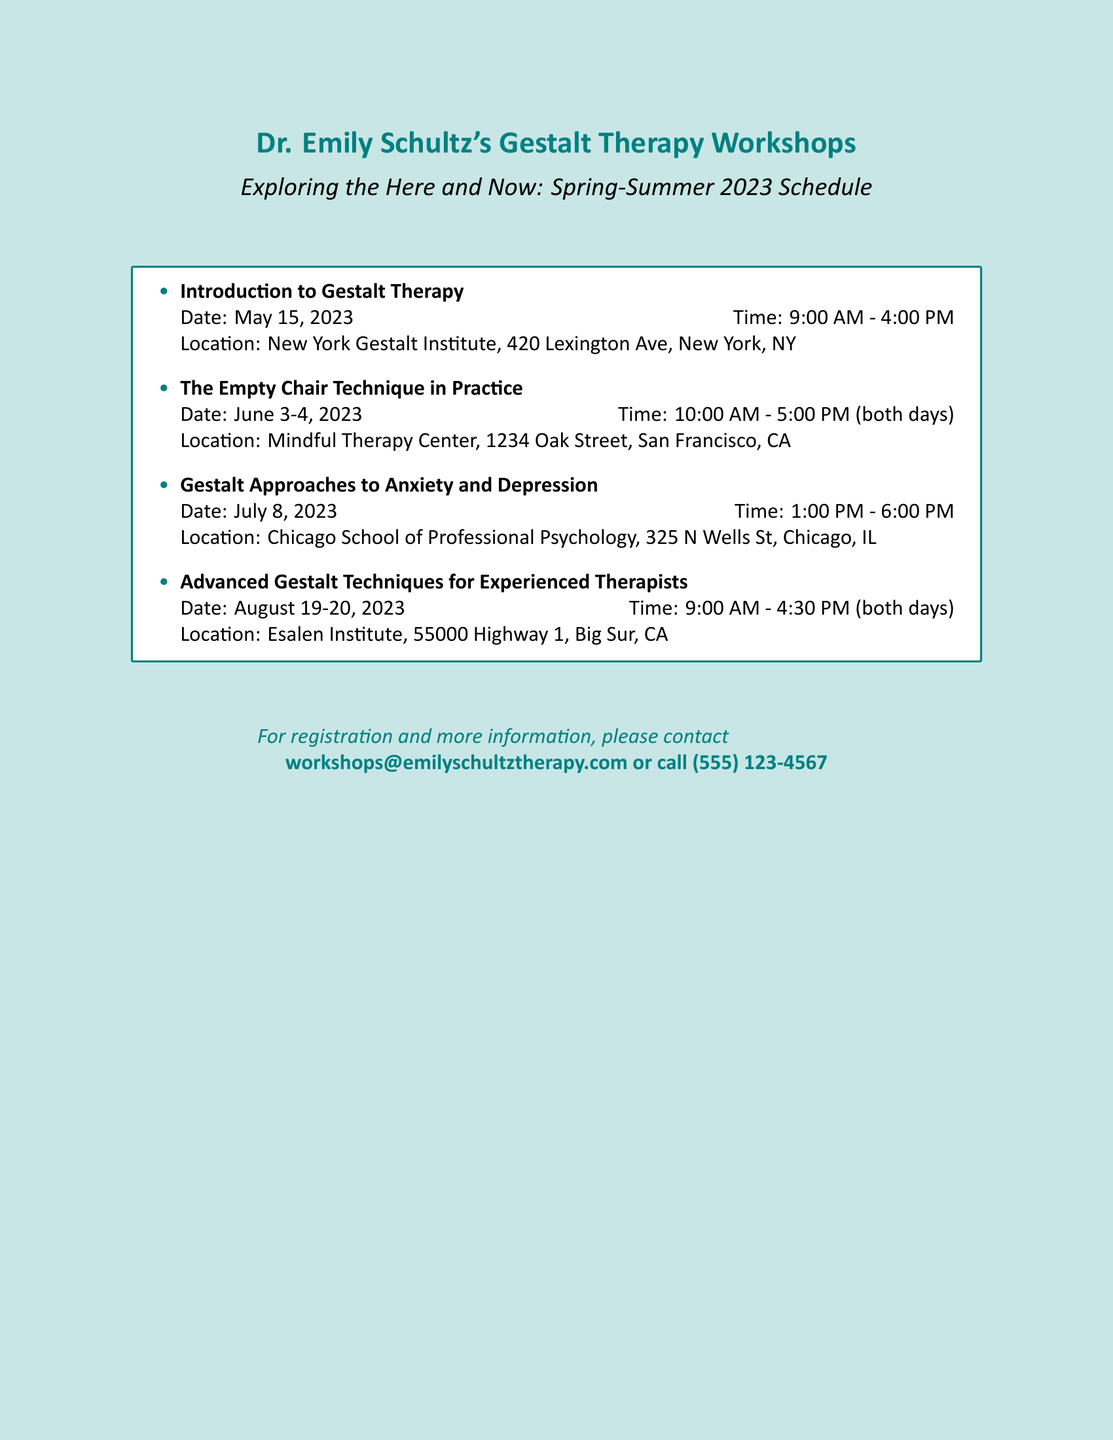What is the title of the first workshop? The title is presented in itemized format at the beginning of the workshop list.
Answer: Introduction to Gestalt Therapy When is the workshop on Gestalt Approaches to Anxiety and Depression scheduled? The date is listed directly next to the workshop title in the document.
Answer: July 8, 2023 How long is the "The Empty Chair Technique in Practice" workshop? The duration is indicated by the dates and times mentioned for the workshop in the document.
Answer: Two days What time does the Advanced Gestalt Techniques for Experienced Therapists workshop start on the first day? The start time is included in the detailed description of the workshop's schedule in the document.
Answer: 9:00 AM Where is the Introduction to Gestalt Therapy workshop being held? The location is provided for each workshop and can be found next to its title and date.
Answer: New York Gestalt Institute, 420 Lexington Ave, New York, NY Which email should be used for registration? The email address is clearly mentioned at the bottom for contacting regarding registration and information.
Answer: workshops@emilyschultztherapy.com How many workshops are scheduled for the summer of 2023? The number of workshops is determined by counting the items listed in the workshop schedule.
Answer: Four What is the ending time for the "The Empty Chair Technique in Practice" workshop on the second day? The ending time is specified in the schedule next to the workshop title.
Answer: 5:00 PM What contact number is provided for inquiries about the workshops? The contact number is listed explicitly in the document at the bottom for further communication.
Answer: (555) 123-4567 